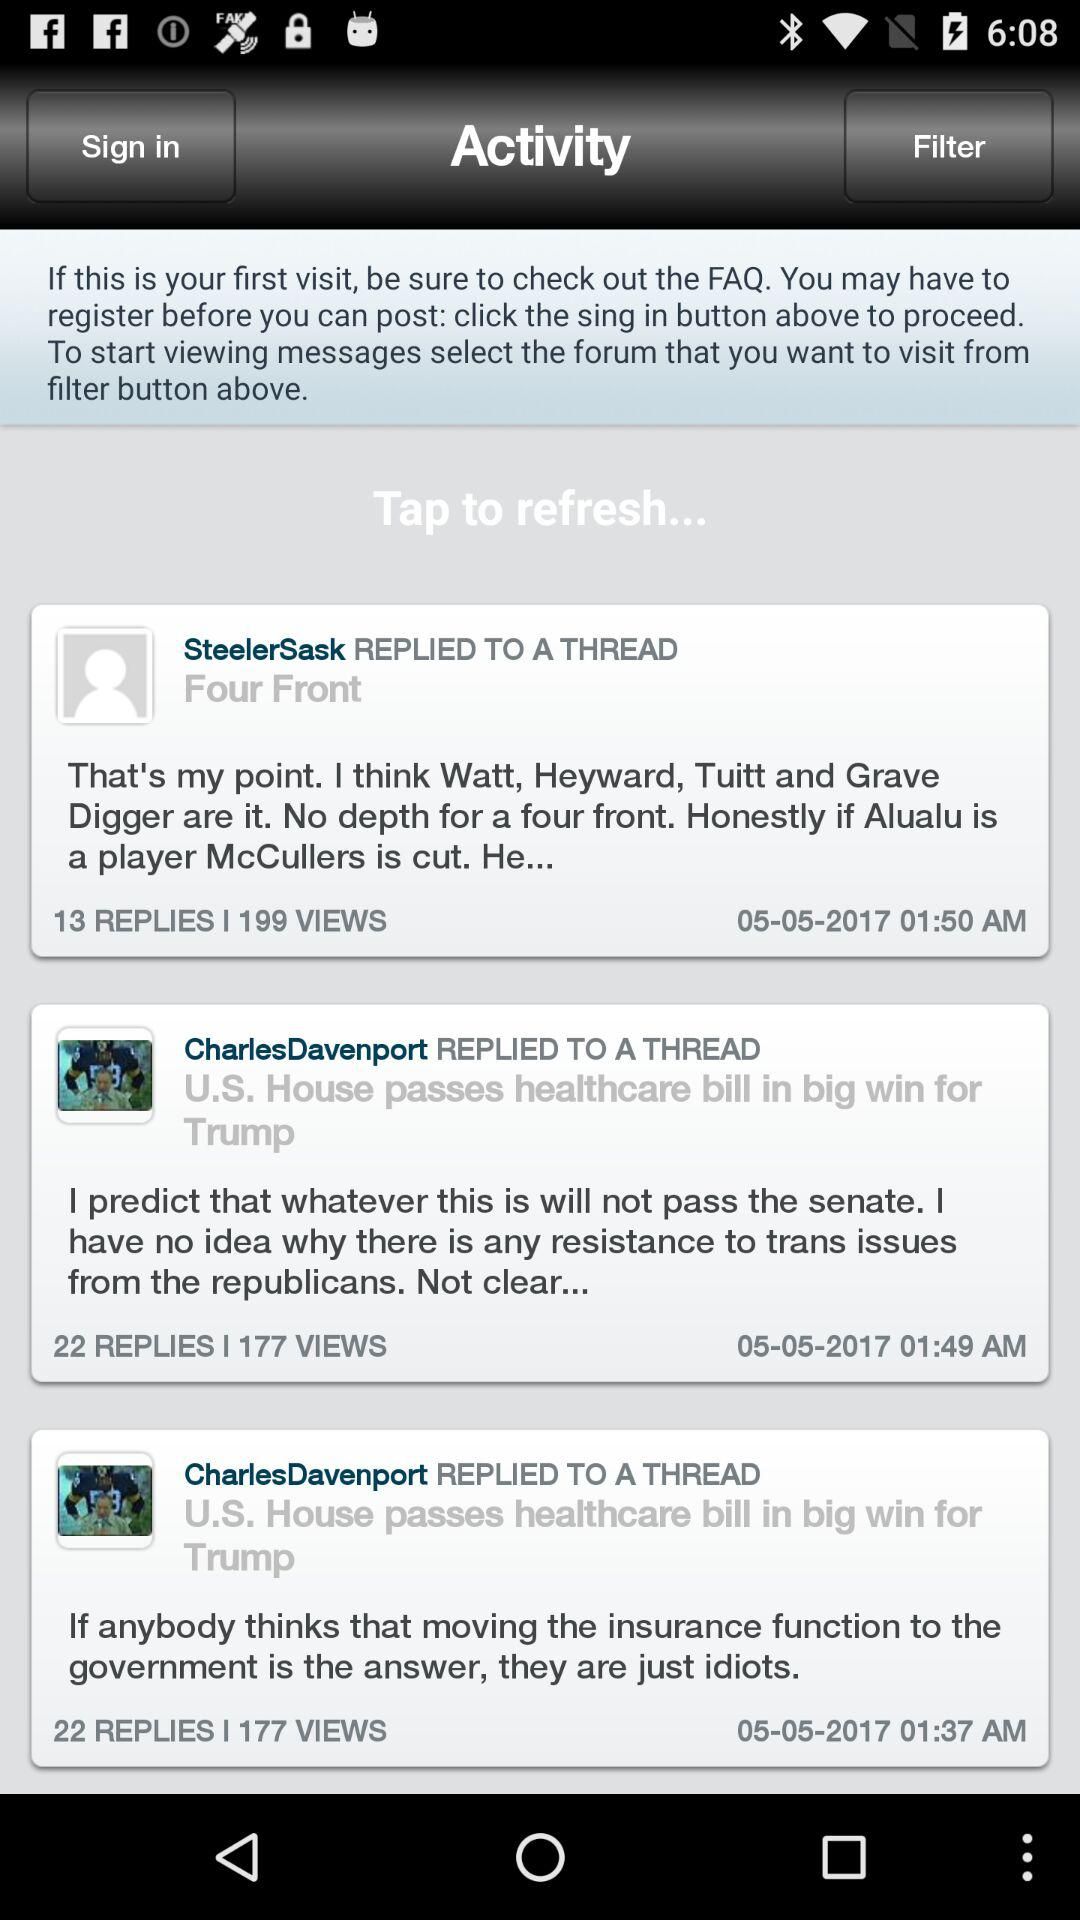How many filters are available?
When the provided information is insufficient, respond with <no answer>. <no answer> 